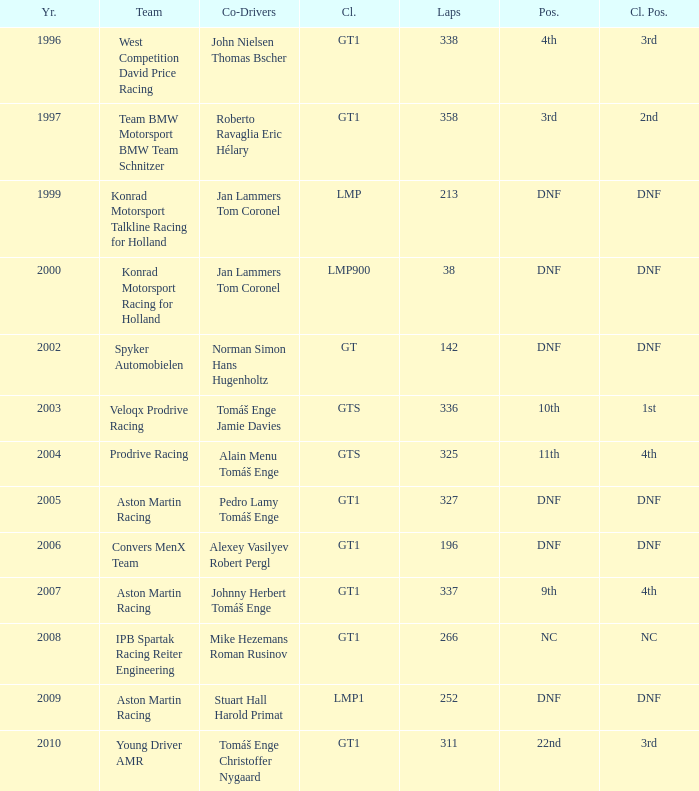Which team ended up 3rd in class, completing 337 laps before the year 2008? West Competition David Price Racing. 